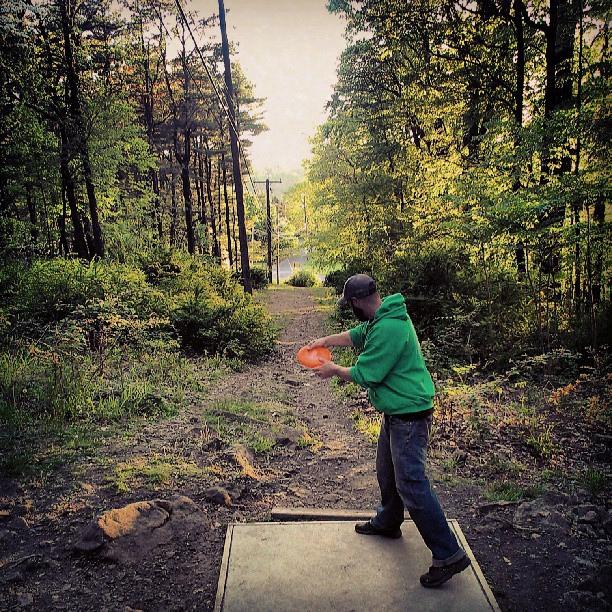How many power poles are there?
Answer briefly. 3. Is the pathway dirt?
Concise answer only. Yes. Is it summer time?
Keep it brief. Yes. What is he throwing?
Keep it brief. Frisbee. What kind of hat is the man wearing?
Give a very brief answer. Baseball. 